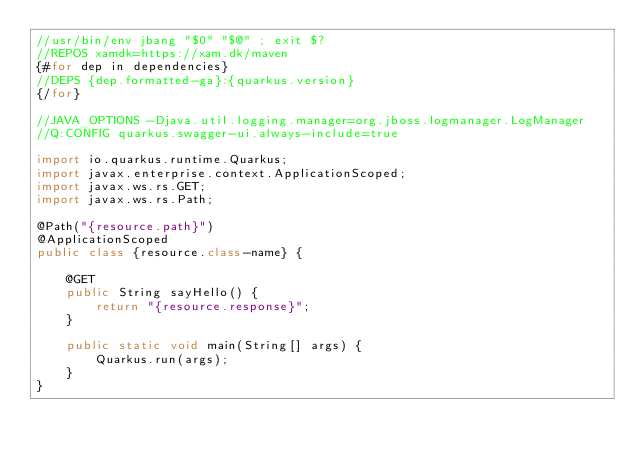Convert code to text. <code><loc_0><loc_0><loc_500><loc_500><_Java_>//usr/bin/env jbang "$0" "$@" ; exit $?
//REPOS xamdk=https://xam.dk/maven
{#for dep in dependencies}
//DEPS {dep.formatted-ga}:{quarkus.version}
{/for}

//JAVA_OPTIONS -Djava.util.logging.manager=org.jboss.logmanager.LogManager
//Q:CONFIG quarkus.swagger-ui.always-include=true

import io.quarkus.runtime.Quarkus;
import javax.enterprise.context.ApplicationScoped;
import javax.ws.rs.GET;
import javax.ws.rs.Path;

@Path("{resource.path}")
@ApplicationScoped
public class {resource.class-name} {

    @GET
    public String sayHello() {
        return "{resource.response}";
    }

    public static void main(String[] args) {
        Quarkus.run(args);
    }
}</code> 